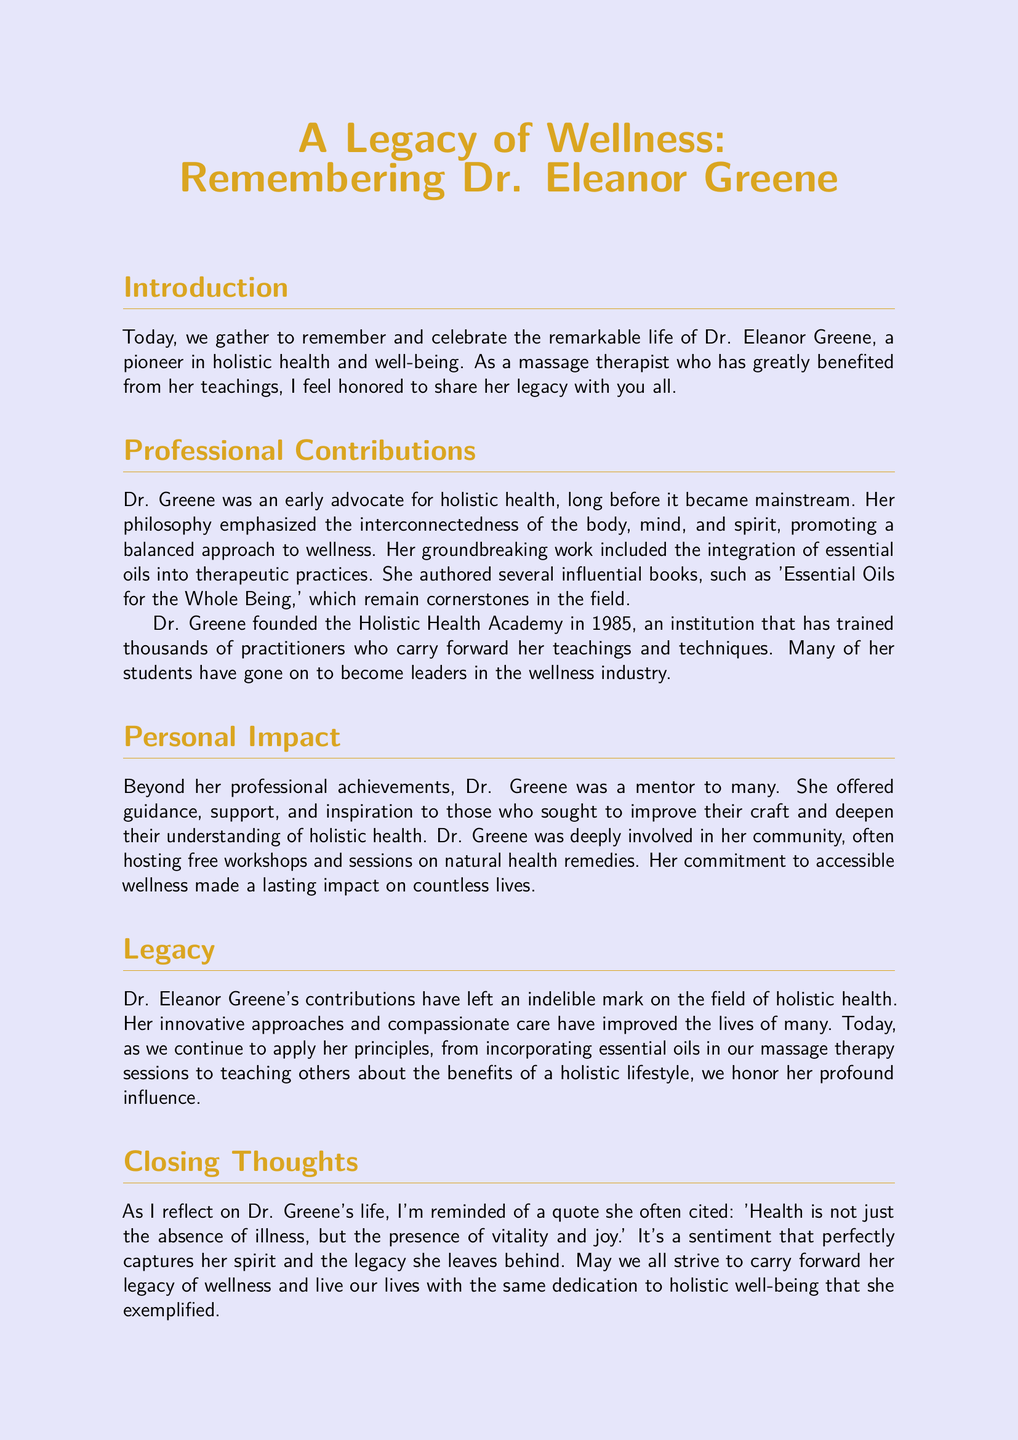What was Dr. Greene's profession? Dr. Greene is referred to as a pioneer in holistic health and well-being, particularly noted for her role as a massage therapist.
Answer: massage therapist When did Dr. Greene found the Holistic Health Academy? The document states the Holistic Health Academy was founded in 1985, marking a significant milestone in her career.
Answer: 1985 What is the title of Dr. Greene's influential book? One of her notable publications mentioned in the document is 'Essential Oils for the Whole Being.'
Answer: Essential Oils for the Whole Being What philosophy did Dr. Greene emphasize? The document highlights that she promoted the interconnectedness of the body, mind, and spirit as part of her wellness approach.
Answer: interconnectedness of the body, mind, and spirit In addition to her professional work, how was Dr. Greene involved in her community? The document states that she hosted free workshops and sessions on natural health remedies, demonstrating her community involvement.
Answer: hosting free workshops What quote did Dr. Greene often cite? The document specifically mentions a quote she often used: 'Health is not just the absence of illness, but the presence of vitality and joy.'
Answer: Health is not just the absence of illness, but the presence of vitality and joy What type of impact did Dr. Greene have on her students? The document notes that she was a mentor to many, providing guidance and support, which indicates her strong influence on her students.
Answer: mentor How did Dr. Greene's teaching influence the wellness industry? It mentions that many of her students have gone on to become leaders in the wellness industry, reflecting her impactful teaching methods.
Answer: leaders in the wellness industry 